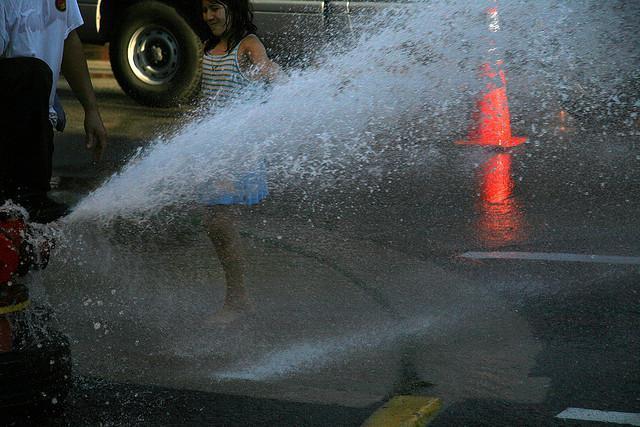How many cones?
Give a very brief answer. 1. How many trucks are in the photo?
Give a very brief answer. 1. How many people are there?
Give a very brief answer. 2. How many sheep in the pen at the bottom?
Give a very brief answer. 0. 